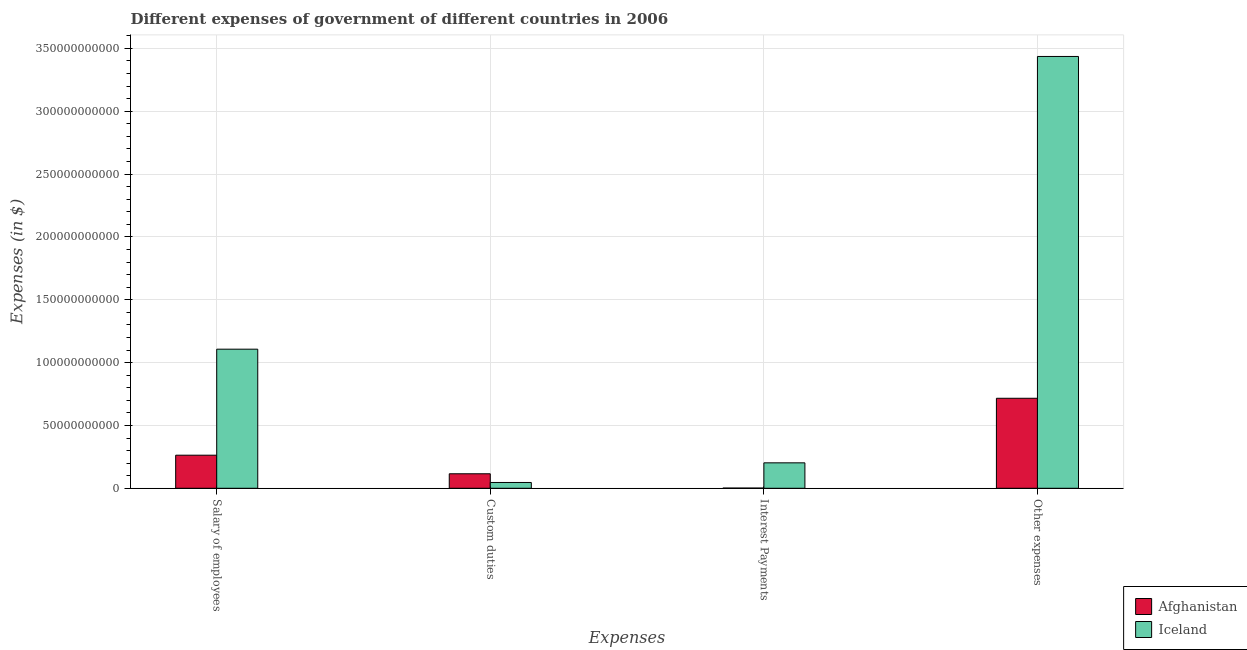How many groups of bars are there?
Give a very brief answer. 4. Are the number of bars on each tick of the X-axis equal?
Give a very brief answer. Yes. What is the label of the 1st group of bars from the left?
Ensure brevity in your answer.  Salary of employees. What is the amount spent on salary of employees in Afghanistan?
Make the answer very short. 2.63e+1. Across all countries, what is the maximum amount spent on other expenses?
Your response must be concise. 3.44e+11. Across all countries, what is the minimum amount spent on interest payments?
Your response must be concise. 1.69e+08. In which country was the amount spent on other expenses maximum?
Provide a succinct answer. Iceland. In which country was the amount spent on other expenses minimum?
Provide a succinct answer. Afghanistan. What is the total amount spent on other expenses in the graph?
Keep it short and to the point. 4.15e+11. What is the difference between the amount spent on other expenses in Iceland and that in Afghanistan?
Offer a very short reply. 2.72e+11. What is the difference between the amount spent on interest payments in Iceland and the amount spent on salary of employees in Afghanistan?
Your answer should be very brief. -6.08e+09. What is the average amount spent on salary of employees per country?
Keep it short and to the point. 6.85e+1. What is the difference between the amount spent on custom duties and amount spent on interest payments in Afghanistan?
Your response must be concise. 1.14e+1. What is the ratio of the amount spent on custom duties in Iceland to that in Afghanistan?
Your response must be concise. 0.4. Is the amount spent on salary of employees in Iceland less than that in Afghanistan?
Give a very brief answer. No. What is the difference between the highest and the second highest amount spent on salary of employees?
Your answer should be compact. 8.44e+1. What is the difference between the highest and the lowest amount spent on interest payments?
Your response must be concise. 2.01e+1. In how many countries, is the amount spent on other expenses greater than the average amount spent on other expenses taken over all countries?
Provide a short and direct response. 1. Is the sum of the amount spent on salary of employees in Iceland and Afghanistan greater than the maximum amount spent on custom duties across all countries?
Ensure brevity in your answer.  Yes. Is it the case that in every country, the sum of the amount spent on salary of employees and amount spent on custom duties is greater than the sum of amount spent on interest payments and amount spent on other expenses?
Provide a short and direct response. Yes. What does the 2nd bar from the left in Custom duties represents?
Ensure brevity in your answer.  Iceland. Are all the bars in the graph horizontal?
Offer a terse response. No. How many countries are there in the graph?
Your response must be concise. 2. Are the values on the major ticks of Y-axis written in scientific E-notation?
Provide a succinct answer. No. Does the graph contain grids?
Provide a short and direct response. Yes. Where does the legend appear in the graph?
Offer a terse response. Bottom right. What is the title of the graph?
Your answer should be compact. Different expenses of government of different countries in 2006. Does "Macao" appear as one of the legend labels in the graph?
Provide a short and direct response. No. What is the label or title of the X-axis?
Your answer should be compact. Expenses. What is the label or title of the Y-axis?
Keep it short and to the point. Expenses (in $). What is the Expenses (in $) of Afghanistan in Salary of employees?
Keep it short and to the point. 2.63e+1. What is the Expenses (in $) in Iceland in Salary of employees?
Your answer should be very brief. 1.11e+11. What is the Expenses (in $) in Afghanistan in Custom duties?
Your answer should be compact. 1.15e+1. What is the Expenses (in $) in Iceland in Custom duties?
Keep it short and to the point. 4.62e+09. What is the Expenses (in $) in Afghanistan in Interest Payments?
Ensure brevity in your answer.  1.69e+08. What is the Expenses (in $) in Iceland in Interest Payments?
Offer a very short reply. 2.03e+1. What is the Expenses (in $) of Afghanistan in Other expenses?
Ensure brevity in your answer.  7.16e+1. What is the Expenses (in $) in Iceland in Other expenses?
Keep it short and to the point. 3.44e+11. Across all Expenses, what is the maximum Expenses (in $) in Afghanistan?
Provide a succinct answer. 7.16e+1. Across all Expenses, what is the maximum Expenses (in $) of Iceland?
Provide a succinct answer. 3.44e+11. Across all Expenses, what is the minimum Expenses (in $) in Afghanistan?
Offer a terse response. 1.69e+08. Across all Expenses, what is the minimum Expenses (in $) of Iceland?
Make the answer very short. 4.62e+09. What is the total Expenses (in $) of Afghanistan in the graph?
Give a very brief answer. 1.10e+11. What is the total Expenses (in $) in Iceland in the graph?
Your answer should be very brief. 4.79e+11. What is the difference between the Expenses (in $) in Afghanistan in Salary of employees and that in Custom duties?
Provide a short and direct response. 1.48e+1. What is the difference between the Expenses (in $) in Iceland in Salary of employees and that in Custom duties?
Ensure brevity in your answer.  1.06e+11. What is the difference between the Expenses (in $) of Afghanistan in Salary of employees and that in Interest Payments?
Provide a short and direct response. 2.62e+1. What is the difference between the Expenses (in $) in Iceland in Salary of employees and that in Interest Payments?
Your response must be concise. 9.04e+1. What is the difference between the Expenses (in $) in Afghanistan in Salary of employees and that in Other expenses?
Keep it short and to the point. -4.53e+1. What is the difference between the Expenses (in $) of Iceland in Salary of employees and that in Other expenses?
Offer a very short reply. -2.33e+11. What is the difference between the Expenses (in $) in Afghanistan in Custom duties and that in Interest Payments?
Provide a short and direct response. 1.14e+1. What is the difference between the Expenses (in $) of Iceland in Custom duties and that in Interest Payments?
Keep it short and to the point. -1.56e+1. What is the difference between the Expenses (in $) of Afghanistan in Custom duties and that in Other expenses?
Keep it short and to the point. -6.01e+1. What is the difference between the Expenses (in $) in Iceland in Custom duties and that in Other expenses?
Ensure brevity in your answer.  -3.39e+11. What is the difference between the Expenses (in $) of Afghanistan in Interest Payments and that in Other expenses?
Give a very brief answer. -7.15e+1. What is the difference between the Expenses (in $) of Iceland in Interest Payments and that in Other expenses?
Make the answer very short. -3.23e+11. What is the difference between the Expenses (in $) in Afghanistan in Salary of employees and the Expenses (in $) in Iceland in Custom duties?
Provide a short and direct response. 2.17e+1. What is the difference between the Expenses (in $) in Afghanistan in Salary of employees and the Expenses (in $) in Iceland in Interest Payments?
Provide a short and direct response. 6.08e+09. What is the difference between the Expenses (in $) of Afghanistan in Salary of employees and the Expenses (in $) of Iceland in Other expenses?
Provide a short and direct response. -3.17e+11. What is the difference between the Expenses (in $) in Afghanistan in Custom duties and the Expenses (in $) in Iceland in Interest Payments?
Your answer should be very brief. -8.71e+09. What is the difference between the Expenses (in $) in Afghanistan in Custom duties and the Expenses (in $) in Iceland in Other expenses?
Your response must be concise. -3.32e+11. What is the difference between the Expenses (in $) in Afghanistan in Interest Payments and the Expenses (in $) in Iceland in Other expenses?
Provide a succinct answer. -3.43e+11. What is the average Expenses (in $) in Afghanistan per Expenses?
Your answer should be very brief. 2.74e+1. What is the average Expenses (in $) of Iceland per Expenses?
Keep it short and to the point. 1.20e+11. What is the difference between the Expenses (in $) of Afghanistan and Expenses (in $) of Iceland in Salary of employees?
Your answer should be compact. -8.44e+1. What is the difference between the Expenses (in $) of Afghanistan and Expenses (in $) of Iceland in Custom duties?
Your response must be concise. 6.92e+09. What is the difference between the Expenses (in $) in Afghanistan and Expenses (in $) in Iceland in Interest Payments?
Keep it short and to the point. -2.01e+1. What is the difference between the Expenses (in $) in Afghanistan and Expenses (in $) in Iceland in Other expenses?
Ensure brevity in your answer.  -2.72e+11. What is the ratio of the Expenses (in $) of Afghanistan in Salary of employees to that in Custom duties?
Your response must be concise. 2.28. What is the ratio of the Expenses (in $) of Iceland in Salary of employees to that in Custom duties?
Ensure brevity in your answer.  23.97. What is the ratio of the Expenses (in $) in Afghanistan in Salary of employees to that in Interest Payments?
Keep it short and to the point. 155.48. What is the ratio of the Expenses (in $) of Iceland in Salary of employees to that in Interest Payments?
Give a very brief answer. 5.47. What is the ratio of the Expenses (in $) of Afghanistan in Salary of employees to that in Other expenses?
Give a very brief answer. 0.37. What is the ratio of the Expenses (in $) in Iceland in Salary of employees to that in Other expenses?
Offer a terse response. 0.32. What is the ratio of the Expenses (in $) of Afghanistan in Custom duties to that in Interest Payments?
Provide a short and direct response. 68.13. What is the ratio of the Expenses (in $) of Iceland in Custom duties to that in Interest Payments?
Your answer should be compact. 0.23. What is the ratio of the Expenses (in $) in Afghanistan in Custom duties to that in Other expenses?
Your answer should be compact. 0.16. What is the ratio of the Expenses (in $) of Iceland in Custom duties to that in Other expenses?
Provide a succinct answer. 0.01. What is the ratio of the Expenses (in $) in Afghanistan in Interest Payments to that in Other expenses?
Provide a short and direct response. 0. What is the ratio of the Expenses (in $) of Iceland in Interest Payments to that in Other expenses?
Your answer should be compact. 0.06. What is the difference between the highest and the second highest Expenses (in $) in Afghanistan?
Give a very brief answer. 4.53e+1. What is the difference between the highest and the second highest Expenses (in $) in Iceland?
Offer a terse response. 2.33e+11. What is the difference between the highest and the lowest Expenses (in $) of Afghanistan?
Provide a succinct answer. 7.15e+1. What is the difference between the highest and the lowest Expenses (in $) of Iceland?
Your answer should be very brief. 3.39e+11. 